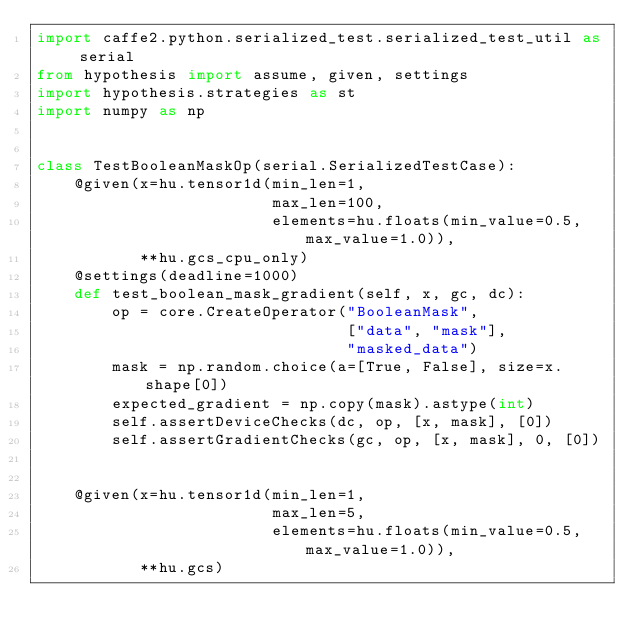<code> <loc_0><loc_0><loc_500><loc_500><_Python_>import caffe2.python.serialized_test.serialized_test_util as serial
from hypothesis import assume, given, settings
import hypothesis.strategies as st
import numpy as np


class TestBooleanMaskOp(serial.SerializedTestCase):
    @given(x=hu.tensor1d(min_len=1,
                         max_len=100,
                         elements=hu.floats(min_value=0.5, max_value=1.0)),
           **hu.gcs_cpu_only)
    @settings(deadline=1000)
    def test_boolean_mask_gradient(self, x, gc, dc):
        op = core.CreateOperator("BooleanMask",
                                 ["data", "mask"],
                                 "masked_data")
        mask = np.random.choice(a=[True, False], size=x.shape[0])
        expected_gradient = np.copy(mask).astype(int)
        self.assertDeviceChecks(dc, op, [x, mask], [0])
        self.assertGradientChecks(gc, op, [x, mask], 0, [0])


    @given(x=hu.tensor1d(min_len=1,
                         max_len=5,
                         elements=hu.floats(min_value=0.5, max_value=1.0)),
           **hu.gcs)</code> 